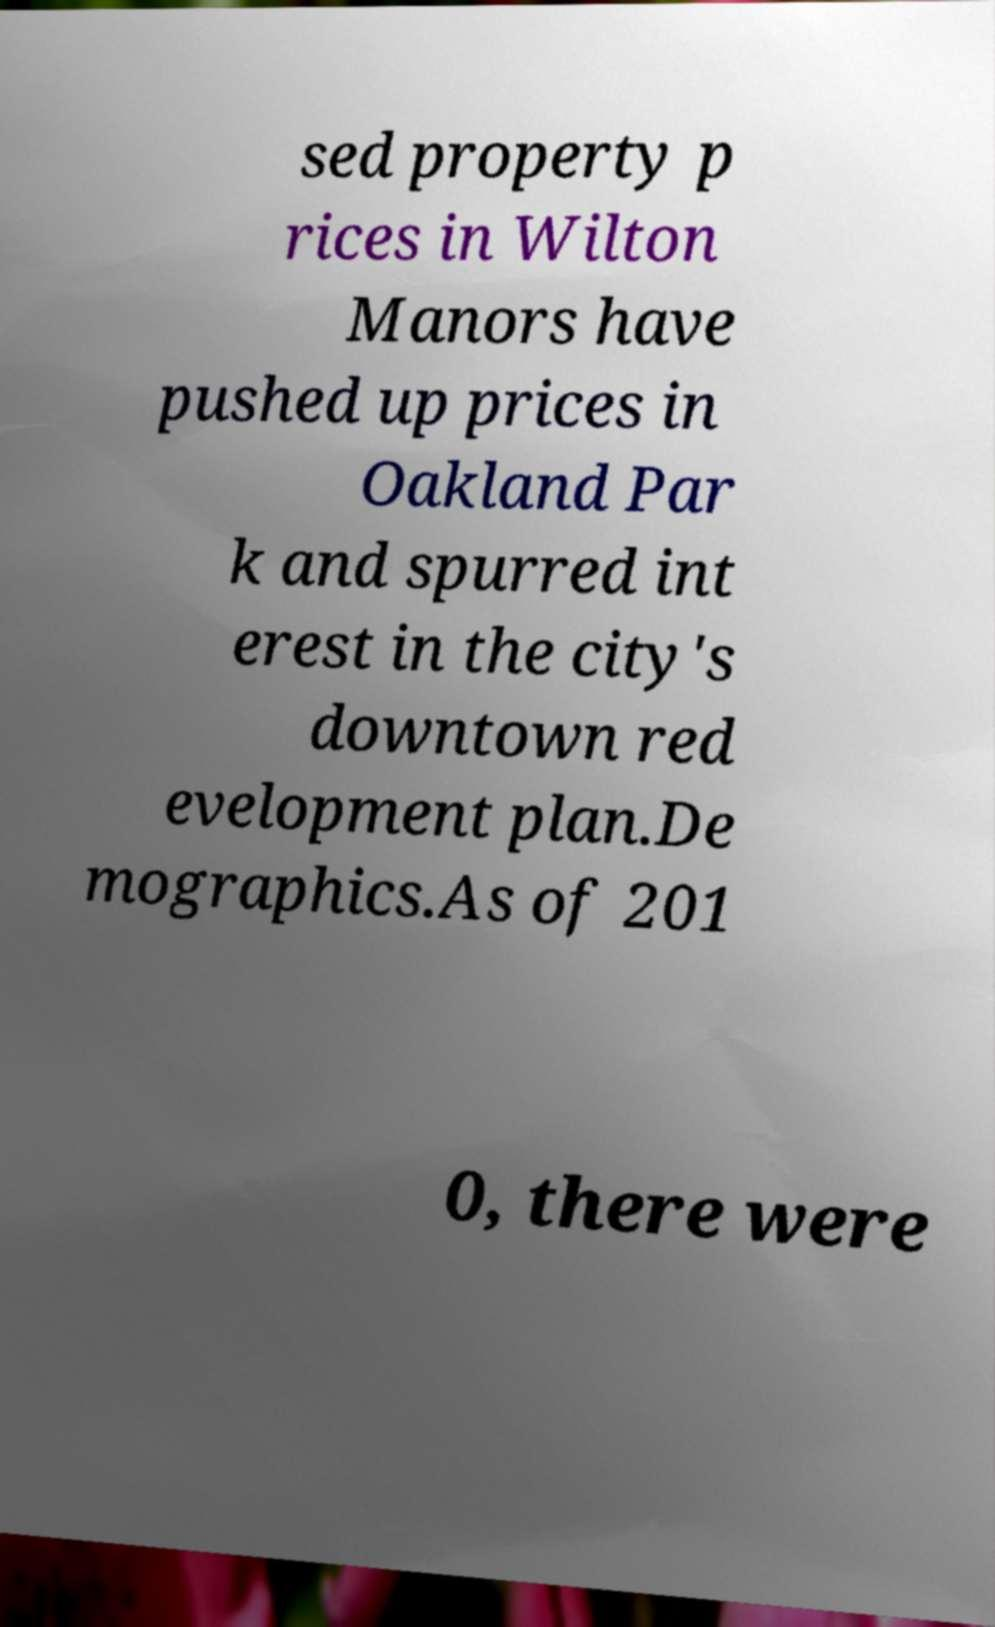There's text embedded in this image that I need extracted. Can you transcribe it verbatim? sed property p rices in Wilton Manors have pushed up prices in Oakland Par k and spurred int erest in the city's downtown red evelopment plan.De mographics.As of 201 0, there were 